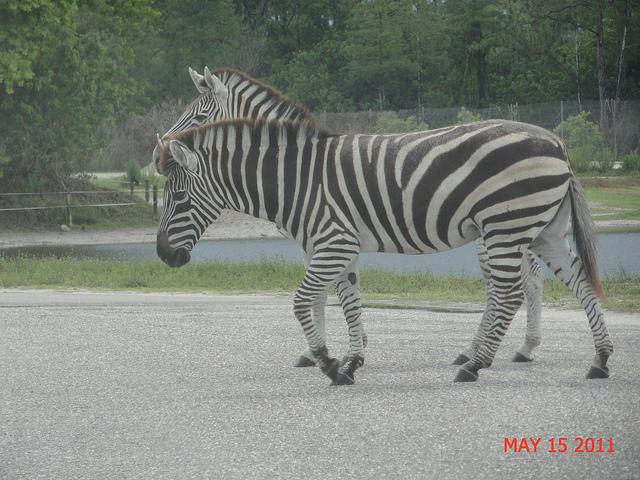Does the animal in the foreground lowering its snout?
Give a very brief answer. Yes. How can you tell these animals are in captivity?
Concise answer only. Fence. Does this photo look washed out?
Answer briefly. No. Are they eating?
Short answer required. No. What continent are we probably seeing?
Be succinct. Africa. How many stripes are on the zebra?
Give a very brief answer. 50. Which direction is the front zebra headed?
Give a very brief answer. Left. Are these zebra standing on a sidewalk?
Answer briefly. Yes. Is the giraffe looking at the camera?
Quick response, please. No. Why are the zebras walking on pavement?
Be succinct. Yes. Is the zebra eating?
Write a very short answer. No. What does the watermark say?
Short answer required. May 15 2011. Do any animals have horns?
Write a very short answer. No. Is one zebra in front of the other?
Concise answer only. Yes. Are the animals real?
Give a very brief answer. Yes. Are they both the same animal?
Quick response, please. Yes. Where is the zebra?
Concise answer only. Zoo. How many zebras are there?
Give a very brief answer. 2. Are these zebras in the wild?
Concise answer only. No. What is the zebra standing on?
Quick response, please. Road. 